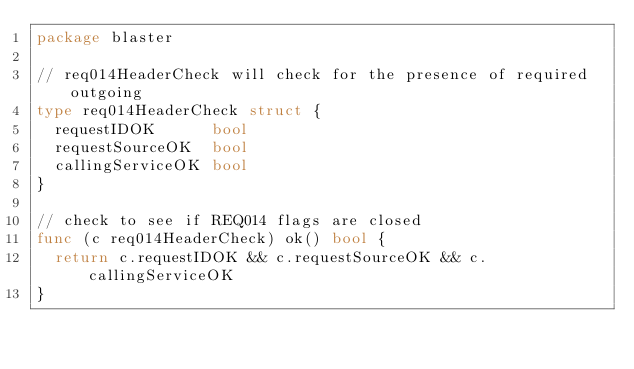<code> <loc_0><loc_0><loc_500><loc_500><_Go_>package blaster

// req014HeaderCheck will check for the presence of required outgoing
type req014HeaderCheck struct {
	requestIDOK      bool
	requestSourceOK  bool
	callingServiceOK bool
}

// check to see if REQ014 flags are closed
func (c req014HeaderCheck) ok() bool {
	return c.requestIDOK && c.requestSourceOK && c.callingServiceOK
}
</code> 